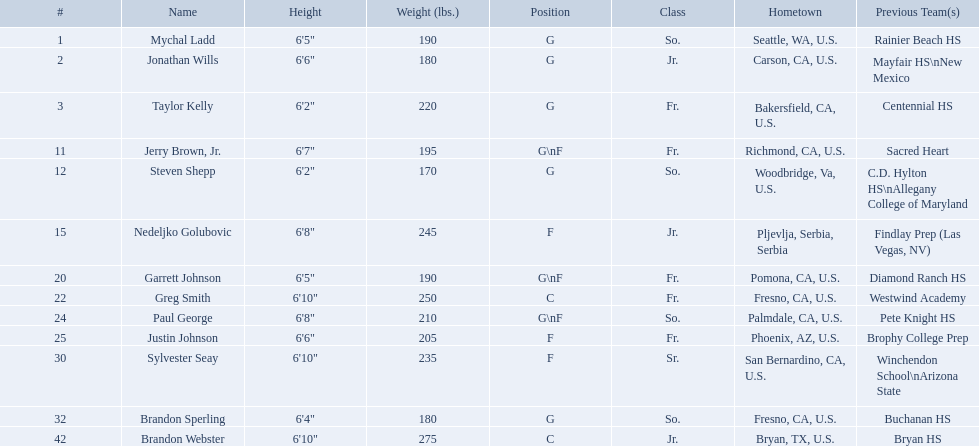Where were all of the players born? So., Jr., Fr., Fr., So., Jr., Fr., Fr., So., Fr., Sr., So., Jr. Who is the one from serbia? Nedeljko Golubovic. Who are all the players in the 2009-10 fresno state bulldogs men's basketball team? Mychal Ladd, Jonathan Wills, Taylor Kelly, Jerry Brown, Jr., Steven Shepp, Nedeljko Golubovic, Garrett Johnson, Greg Smith, Paul George, Justin Johnson, Sylvester Seay, Brandon Sperling, Brandon Webster. Of these players, who are the ones who play forward? Jerry Brown, Jr., Nedeljko Golubovic, Garrett Johnson, Paul George, Justin Johnson, Sylvester Seay. Of these players, which ones only play forward and no other position? Nedeljko Golubovic, Justin Johnson, Sylvester Seay. Of these players, who is the shortest? Justin Johnson. What are the names for all players? Mychal Ladd, Jonathan Wills, Taylor Kelly, Jerry Brown, Jr., Steven Shepp, Nedeljko Golubovic, Garrett Johnson, Greg Smith, Paul George, Justin Johnson, Sylvester Seay, Brandon Sperling, Brandon Webster. Which players are taller than 6'8? Nedeljko Golubovic, Greg Smith, Paul George, Sylvester Seay, Brandon Webster. How tall is paul george? 6'8". How tall is greg smith? 6'10". Of these two, which it tallest? Greg Smith. Who are all the players? Mychal Ladd, Jonathan Wills, Taylor Kelly, Jerry Brown, Jr., Steven Shepp, Nedeljko Golubovic, Garrett Johnson, Greg Smith, Paul George, Justin Johnson, Sylvester Seay, Brandon Sperling, Brandon Webster. How tall are they? 6'5", 6'6", 6'2", 6'7", 6'2", 6'8", 6'5", 6'10", 6'8", 6'6", 6'10", 6'4", 6'10". What about just paul george and greg smitih? 6'10", 6'8". And which of the two is taller? Greg Smith. What are the monikers for all participants? Mychal Ladd, Jonathan Wills, Taylor Kelly, Jerry Brown, Jr., Steven Shepp, Nedeljko Golubovic, Garrett Johnson, Greg Smith, Paul George, Justin Johnson, Sylvester Seay, Brandon Sperling, Brandon Webster. Give me the full table as a dictionary. {'header': ['#', 'Name', 'Height', 'Weight (lbs.)', 'Position', 'Class', 'Hometown', 'Previous Team(s)'], 'rows': [['1', 'Mychal Ladd', '6\'5"', '190', 'G', 'So.', 'Seattle, WA, U.S.', 'Rainier Beach HS'], ['2', 'Jonathan Wills', '6\'6"', '180', 'G', 'Jr.', 'Carson, CA, U.S.', 'Mayfair HS\\nNew Mexico'], ['3', 'Taylor Kelly', '6\'2"', '220', 'G', 'Fr.', 'Bakersfield, CA, U.S.', 'Centennial HS'], ['11', 'Jerry Brown, Jr.', '6\'7"', '195', 'G\\nF', 'Fr.', 'Richmond, CA, U.S.', 'Sacred Heart'], ['12', 'Steven Shepp', '6\'2"', '170', 'G', 'So.', 'Woodbridge, Va, U.S.', 'C.D. Hylton HS\\nAllegany College of Maryland'], ['15', 'Nedeljko Golubovic', '6\'8"', '245', 'F', 'Jr.', 'Pljevlja, Serbia, Serbia', 'Findlay Prep (Las Vegas, NV)'], ['20', 'Garrett Johnson', '6\'5"', '190', 'G\\nF', 'Fr.', 'Pomona, CA, U.S.', 'Diamond Ranch HS'], ['22', 'Greg Smith', '6\'10"', '250', 'C', 'Fr.', 'Fresno, CA, U.S.', 'Westwind Academy'], ['24', 'Paul George', '6\'8"', '210', 'G\\nF', 'So.', 'Palmdale, CA, U.S.', 'Pete Knight HS'], ['25', 'Justin Johnson', '6\'6"', '205', 'F', 'Fr.', 'Phoenix, AZ, U.S.', 'Brophy College Prep'], ['30', 'Sylvester Seay', '6\'10"', '235', 'F', 'Sr.', 'San Bernardino, CA, U.S.', 'Winchendon School\\nArizona State'], ['32', 'Brandon Sperling', '6\'4"', '180', 'G', 'So.', 'Fresno, CA, U.S.', 'Buchanan HS'], ['42', 'Brandon Webster', '6\'10"', '275', 'C', 'Jr.', 'Bryan, TX, U.S.', 'Bryan HS']]} Which players have a height exceeding 6'8? Nedeljko Golubovic, Greg Smith, Paul George, Sylvester Seay, Brandon Webster. How high is paul george? 6'8". What is greg smith's stature? 6'10". Out of these two, which one is taller? Greg Smith. What are the designations for each player? Mychal Ladd, Jonathan Wills, Taylor Kelly, Jerry Brown, Jr., Steven Shepp, Nedeljko Golubovic, Garrett Johnson, Greg Smith, Paul George, Justin Johnson, Sylvester Seay, Brandon Sperling, Brandon Webster. Which competitors stand taller than 6'8? Nedeljko Golubovic, Greg Smith, Paul George, Sylvester Seay, Brandon Webster. What is paul george's height? 6'8". How tall is greg smith? 6'10". Between these two, who has the greater height? Greg Smith. Which participants are forwards? Nedeljko Golubovic, Paul George, Justin Johnson, Sylvester Seay. What are their statures? Nedeljko Golubovic, 6'8", Paul George, 6'8", Justin Johnson, 6'6", Sylvester Seay, 6'10". Of these participants, who is the most vertically challenged? Justin Johnson. What are the enumerated divisions of the players? So., Jr., Fr., Fr., So., Jr., Fr., Fr., So., Fr., Sr., So., Jr. Which among these is not from the us? Jr. To which appellation does that record pertain to? Nedeljko Golubovic. In which locations were all the players born? So., Jr., Fr., Fr., So., Jr., Fr., Fr., So., Fr., Sr., So., Jr. Who is the serbian representative? Nedeljko Golubovic. Who are the members of the 2009-10 fresno state bulldogs men's basketball team? Mychal Ladd, Jonathan Wills, Taylor Kelly, Jerry Brown, Jr., Steven Shepp, Nedeljko Golubovic, Garrett Johnson, Greg Smith, Paul George, Justin Johnson, Sylvester Seay, Brandon Sperling, Brandon Webster. Among them, who are the forwards? Jerry Brown, Jr., Nedeljko Golubovic, Garrett Johnson, Paul George, Justin Johnson, Sylvester Seay. Which ones exclusively play as forwards without any other position? Nedeljko Golubovic, Justin Johnson, Sylvester Seay. Out of these players, who has the least height? Justin Johnson. Who are the participants of the 2009-10 fresno state bulldogs men's basketball roster? Mychal Ladd, Jonathan Wills, Taylor Kelly, Jerry Brown, Jr., Steven Shepp, Nedeljko Golubovic, Garrett Johnson, Greg Smith, Paul George, Justin Johnson, Sylvester Seay, Brandon Sperling, Brandon Webster. What are their heights? 6'5", 6'6", 6'2", 6'7", 6'2", 6'8", 6'5", 6'10", 6'8", 6'6", 6'10", 6'4", 6'10". Could you parse the entire table? {'header': ['#', 'Name', 'Height', 'Weight (lbs.)', 'Position', 'Class', 'Hometown', 'Previous Team(s)'], 'rows': [['1', 'Mychal Ladd', '6\'5"', '190', 'G', 'So.', 'Seattle, WA, U.S.', 'Rainier Beach HS'], ['2', 'Jonathan Wills', '6\'6"', '180', 'G', 'Jr.', 'Carson, CA, U.S.', 'Mayfair HS\\nNew Mexico'], ['3', 'Taylor Kelly', '6\'2"', '220', 'G', 'Fr.', 'Bakersfield, CA, U.S.', 'Centennial HS'], ['11', 'Jerry Brown, Jr.', '6\'7"', '195', 'G\\nF', 'Fr.', 'Richmond, CA, U.S.', 'Sacred Heart'], ['12', 'Steven Shepp', '6\'2"', '170', 'G', 'So.', 'Woodbridge, Va, U.S.', 'C.D. Hylton HS\\nAllegany College of Maryland'], ['15', 'Nedeljko Golubovic', '6\'8"', '245', 'F', 'Jr.', 'Pljevlja, Serbia, Serbia', 'Findlay Prep (Las Vegas, NV)'], ['20', 'Garrett Johnson', '6\'5"', '190', 'G\\nF', 'Fr.', 'Pomona, CA, U.S.', 'Diamond Ranch HS'], ['22', 'Greg Smith', '6\'10"', '250', 'C', 'Fr.', 'Fresno, CA, U.S.', 'Westwind Academy'], ['24', 'Paul George', '6\'8"', '210', 'G\\nF', 'So.', 'Palmdale, CA, U.S.', 'Pete Knight HS'], ['25', 'Justin Johnson', '6\'6"', '205', 'F', 'Fr.', 'Phoenix, AZ, U.S.', 'Brophy College Prep'], ['30', 'Sylvester Seay', '6\'10"', '235', 'F', 'Sr.', 'San Bernardino, CA, U.S.', 'Winchendon School\\nArizona State'], ['32', 'Brandon Sperling', '6\'4"', '180', 'G', 'So.', 'Fresno, CA, U.S.', 'Buchanan HS'], ['42', 'Brandon Webster', '6\'10"', '275', 'C', 'Jr.', 'Bryan, TX, U.S.', 'Bryan HS']]} What is the shortest height? 6'2", 6'2". What is the lowest weight? 6'2". Which athlete possesses it? Steven Shepp. Where did all the players originate? So., Jr., Fr., Fr., So., Jr., Fr., Fr., So., Fr., Sr., So., Jr. Who is the individual from serbia? Nedeljko Golubovic. In which countries were all the players born? So., Jr., Fr., Fr., So., Jr., Fr., Fr., So., Fr., Sr., So., Jr. Who among them hails from serbia? Nedeljko Golubovic. Who are the players in forward positions? Nedeljko Golubovic, Paul George, Justin Johnson, Sylvester Seay. What are their respective heights? Nedeljko Golubovic, 6'8", Paul George, 6'8", Justin Johnson, 6'6", Sylvester Seay, 6'10". Among them, who is the least tall? Justin Johnson. What are the names of all the players? Mychal Ladd, Jonathan Wills, Taylor Kelly, Jerry Brown, Jr., Steven Shepp, Nedeljko Golubovic, Garrett Johnson, Greg Smith, Paul George, Justin Johnson, Sylvester Seay, Brandon Sperling, Brandon Webster. Who are the players with a height greater than 6'8? Nedeljko Golubovic, Greg Smith, Paul George, Sylvester Seay, Brandon Webster. What is paul george's height? 6'8". What is greg smith's height? 6'10". Between these two, who is taller? Greg Smith. What are the specific positions? G, G, G\nF, G. Which weights are in grams? 190, 170, 180. What height is below 6'3"? 6'2". What is the name? Steven Shepp. What positions are being mentioned? G, G, G\nF, G. What are the weights measured in grams? 190, 170, 180. What height is shorter than 6'3"? 6'2". What is the name in question? Steven Shepp. 